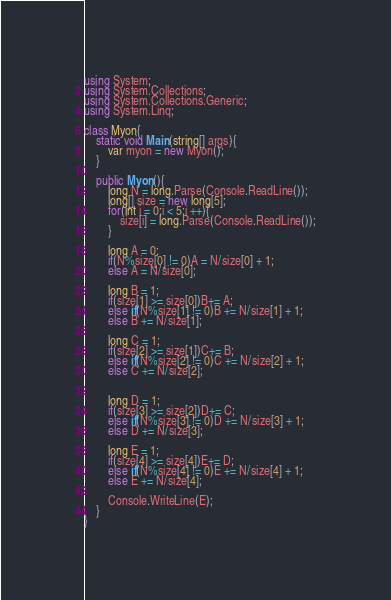<code> <loc_0><loc_0><loc_500><loc_500><_C#_>using System;
using System.Collections;
using System.Collections.Generic;
using System.Linq;

class Myon{
    static void Main(string[] args){
        var myon = new Myon();
    }

    public Myon(){
        long N = long.Parse(Console.ReadLine());
        long[] size = new long[5];
        for(int i = 0;i < 5;i ++){
            size[i] = long.Parse(Console.ReadLine());
        }

        long A = 0;
        if(N%size[0] != 0)A = N/size[0] + 1;
        else A = N/size[0];

        long B = 1;
        if(size[1] >= size[0])B+= A;
        else if(N%size[1] != 0)B += N/size[1] + 1;
        else B += N/size[1];

        long C = 1;
        if(size[2] >= size[1])C+= B;
        else if(N%size[2] != 0)C += N/size[2] + 1;
        else C += N/size[2];

        
        long D = 1;
        if(size[3] >= size[2])D+= C;
        else if(N%size[3] != 0)D += N/size[3] + 1;
        else D += N/size[3];
        
        long E = 1;
        if(size[4] >= size[4])E+= D;
        else if(N%size[4] != 0)E += N/size[4] + 1;
        else E += N/size[4];

        Console.WriteLine(E);
    }
}</code> 